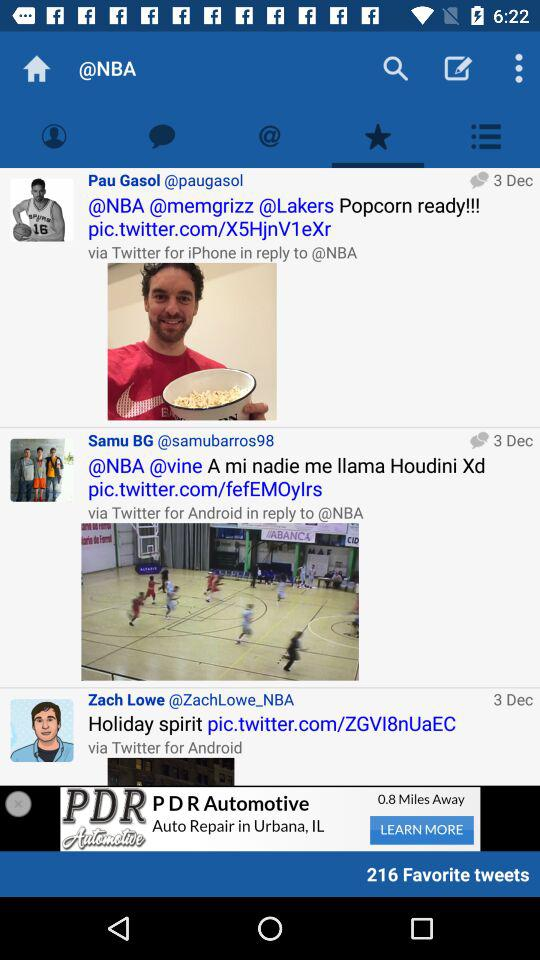What app did you use to respond to NBA? To respond to the NBA "Twitter for iPhone" and "Twitter for Android" are used. 